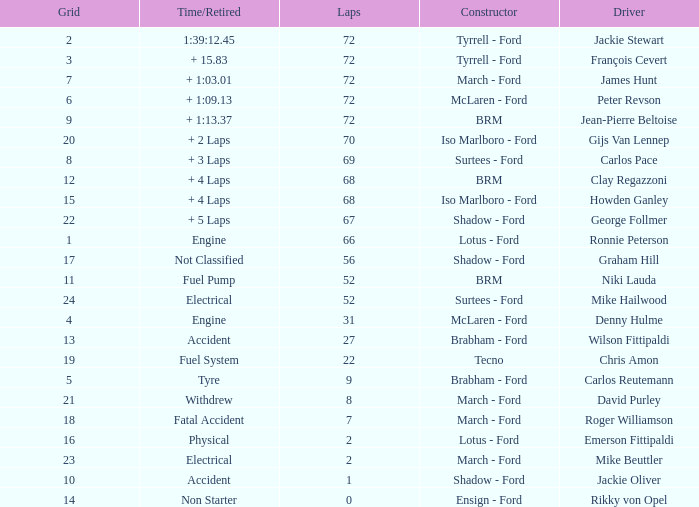What is the top grid that laps less than 66 and a retried engine? 4.0. 